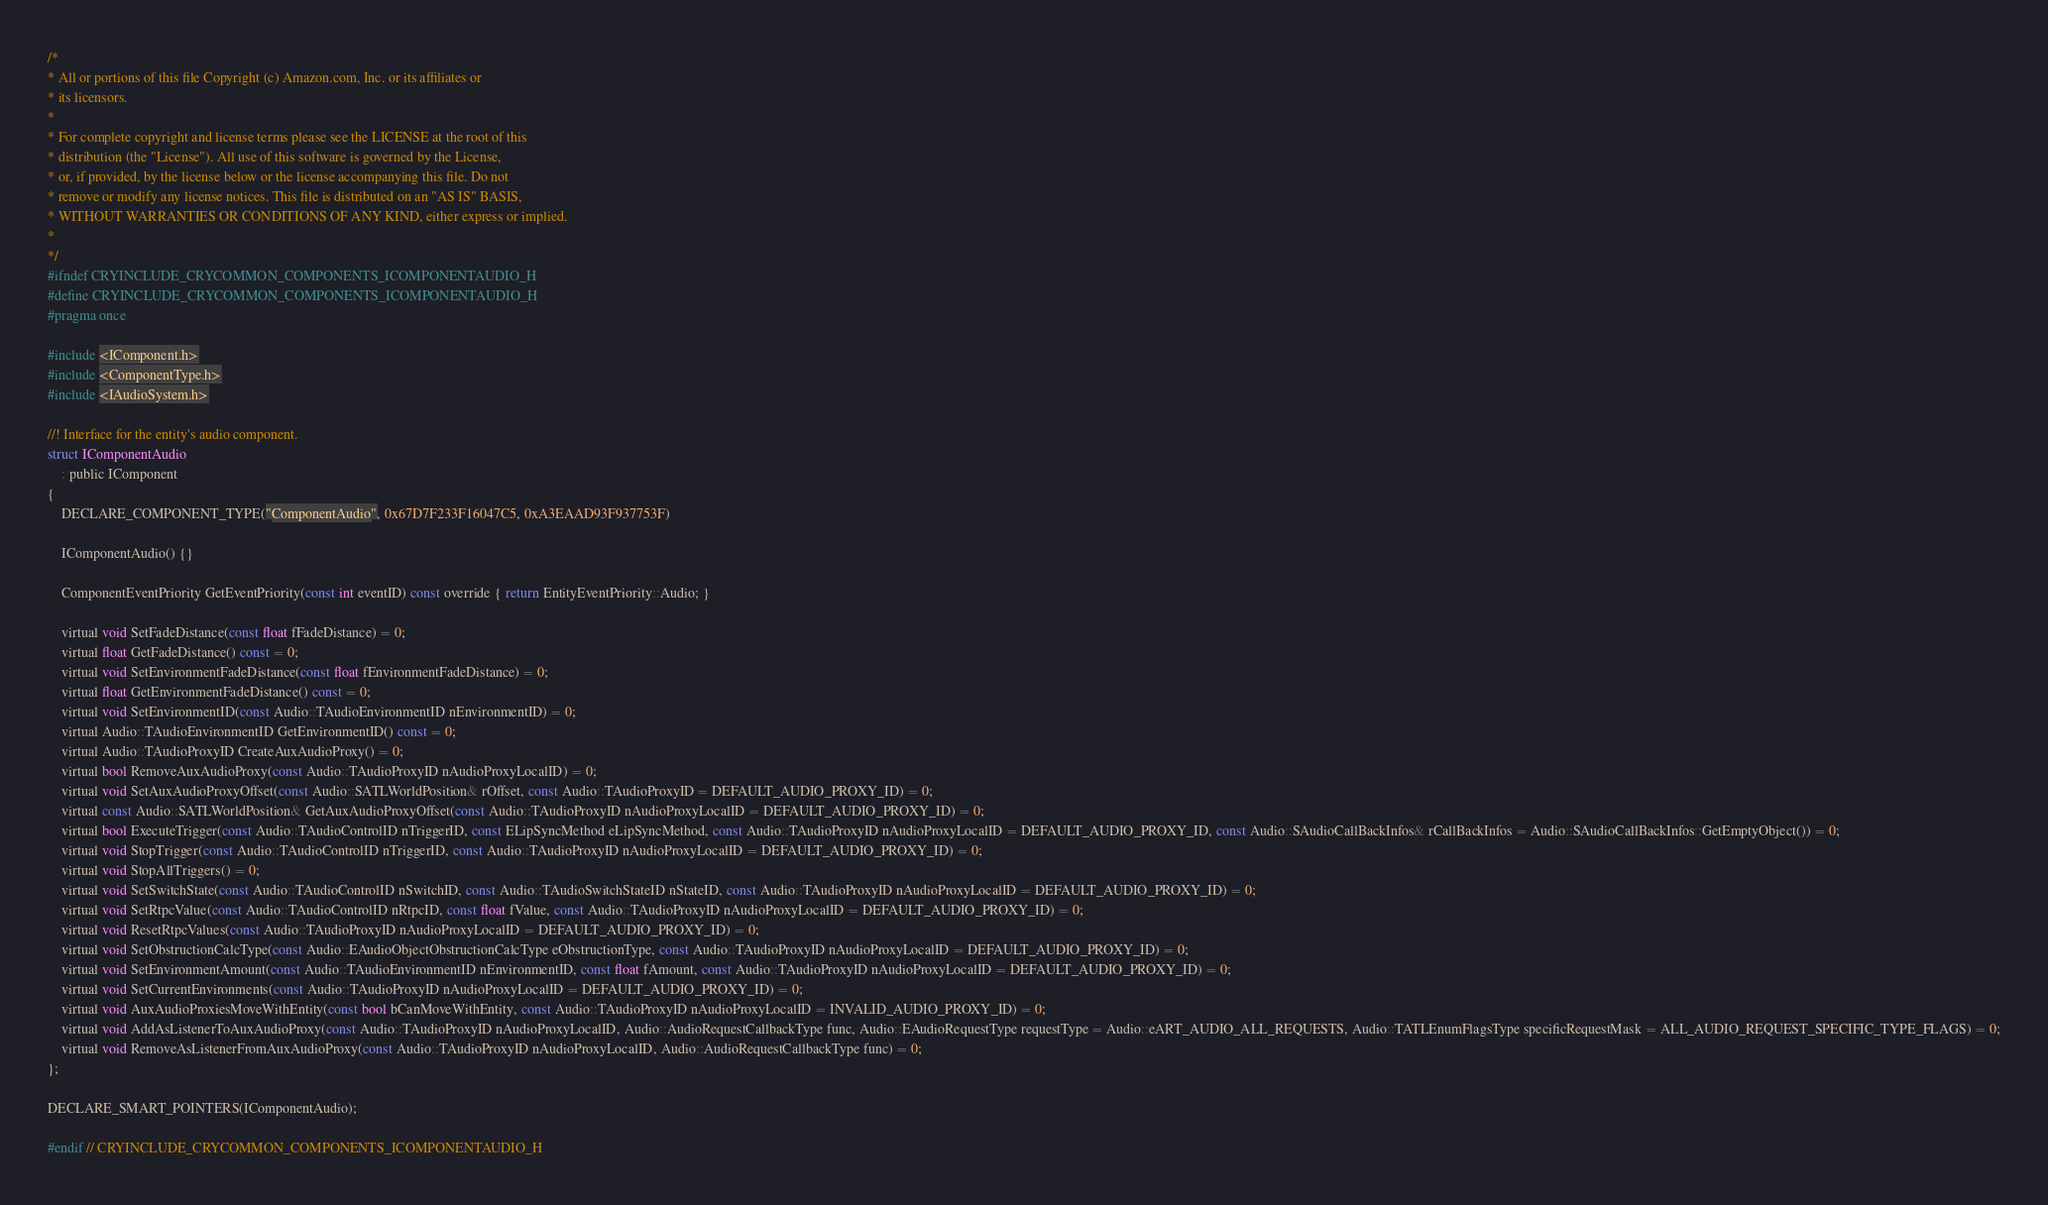<code> <loc_0><loc_0><loc_500><loc_500><_C_>/*
* All or portions of this file Copyright (c) Amazon.com, Inc. or its affiliates or
* its licensors.
*
* For complete copyright and license terms please see the LICENSE at the root of this
* distribution (the "License"). All use of this software is governed by the License,
* or, if provided, by the license below or the license accompanying this file. Do not
* remove or modify any license notices. This file is distributed on an "AS IS" BASIS,
* WITHOUT WARRANTIES OR CONDITIONS OF ANY KIND, either express or implied.
*
*/
#ifndef CRYINCLUDE_CRYCOMMON_COMPONENTS_ICOMPONENTAUDIO_H
#define CRYINCLUDE_CRYCOMMON_COMPONENTS_ICOMPONENTAUDIO_H
#pragma once

#include <IComponent.h>
#include <ComponentType.h>
#include <IAudioSystem.h>

//! Interface for the entity's audio component.
struct IComponentAudio
    : public IComponent
{
    DECLARE_COMPONENT_TYPE("ComponentAudio", 0x67D7F233F16047C5, 0xA3EAAD93F937753F)

    IComponentAudio() {}

    ComponentEventPriority GetEventPriority(const int eventID) const override { return EntityEventPriority::Audio; }

    virtual void SetFadeDistance(const float fFadeDistance) = 0;
    virtual float GetFadeDistance() const = 0;
    virtual void SetEnvironmentFadeDistance(const float fEnvironmentFadeDistance) = 0;
    virtual float GetEnvironmentFadeDistance() const = 0;
    virtual void SetEnvironmentID(const Audio::TAudioEnvironmentID nEnvironmentID) = 0;
    virtual Audio::TAudioEnvironmentID GetEnvironmentID() const = 0;
    virtual Audio::TAudioProxyID CreateAuxAudioProxy() = 0;
    virtual bool RemoveAuxAudioProxy(const Audio::TAudioProxyID nAudioProxyLocalID) = 0;
    virtual void SetAuxAudioProxyOffset(const Audio::SATLWorldPosition& rOffset, const Audio::TAudioProxyID = DEFAULT_AUDIO_PROXY_ID) = 0;
    virtual const Audio::SATLWorldPosition& GetAuxAudioProxyOffset(const Audio::TAudioProxyID nAudioProxyLocalID = DEFAULT_AUDIO_PROXY_ID) = 0;
    virtual bool ExecuteTrigger(const Audio::TAudioControlID nTriggerID, const ELipSyncMethod eLipSyncMethod, const Audio::TAudioProxyID nAudioProxyLocalID = DEFAULT_AUDIO_PROXY_ID, const Audio::SAudioCallBackInfos& rCallBackInfos = Audio::SAudioCallBackInfos::GetEmptyObject()) = 0;
    virtual void StopTrigger(const Audio::TAudioControlID nTriggerID, const Audio::TAudioProxyID nAudioProxyLocalID = DEFAULT_AUDIO_PROXY_ID) = 0;
    virtual void StopAllTriggers() = 0;
    virtual void SetSwitchState(const Audio::TAudioControlID nSwitchID, const Audio::TAudioSwitchStateID nStateID, const Audio::TAudioProxyID nAudioProxyLocalID = DEFAULT_AUDIO_PROXY_ID) = 0;
    virtual void SetRtpcValue(const Audio::TAudioControlID nRtpcID, const float fValue, const Audio::TAudioProxyID nAudioProxyLocalID = DEFAULT_AUDIO_PROXY_ID) = 0;
    virtual void ResetRtpcValues(const Audio::TAudioProxyID nAudioProxyLocalID = DEFAULT_AUDIO_PROXY_ID) = 0;
    virtual void SetObstructionCalcType(const Audio::EAudioObjectObstructionCalcType eObstructionType, const Audio::TAudioProxyID nAudioProxyLocalID = DEFAULT_AUDIO_PROXY_ID) = 0;
    virtual void SetEnvironmentAmount(const Audio::TAudioEnvironmentID nEnvironmentID, const float fAmount, const Audio::TAudioProxyID nAudioProxyLocalID = DEFAULT_AUDIO_PROXY_ID) = 0;
    virtual void SetCurrentEnvironments(const Audio::TAudioProxyID nAudioProxyLocalID = DEFAULT_AUDIO_PROXY_ID) = 0;
    virtual void AuxAudioProxiesMoveWithEntity(const bool bCanMoveWithEntity, const Audio::TAudioProxyID nAudioProxyLocalID = INVALID_AUDIO_PROXY_ID) = 0;
    virtual void AddAsListenerToAuxAudioProxy(const Audio::TAudioProxyID nAudioProxyLocalID, Audio::AudioRequestCallbackType func, Audio::EAudioRequestType requestType = Audio::eART_AUDIO_ALL_REQUESTS, Audio::TATLEnumFlagsType specificRequestMask = ALL_AUDIO_REQUEST_SPECIFIC_TYPE_FLAGS) = 0;
    virtual void RemoveAsListenerFromAuxAudioProxy(const Audio::TAudioProxyID nAudioProxyLocalID, Audio::AudioRequestCallbackType func) = 0;
};

DECLARE_SMART_POINTERS(IComponentAudio);

#endif // CRYINCLUDE_CRYCOMMON_COMPONENTS_ICOMPONENTAUDIO_H</code> 